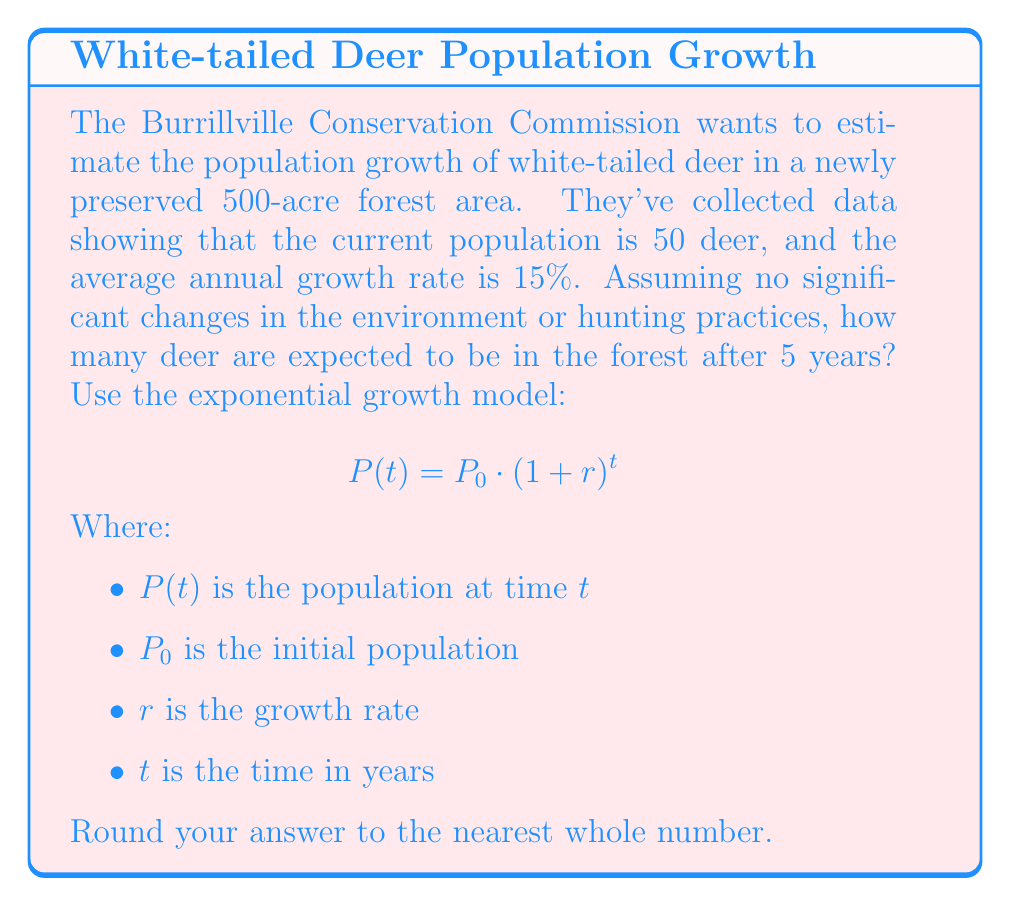Give your solution to this math problem. To solve this problem, we'll use the exponential growth model and plug in the given values:

1. Initial population, $P_0 = 50$ deer
2. Growth rate, $r = 15\% = 0.15$
3. Time, $t = 5$ years

Let's substitute these values into the formula:

$$P(5) = 50 \cdot (1 + 0.15)^5$$

Now, let's calculate step by step:

1. First, calculate $(1 + 0.15)$:
   $1 + 0.15 = 1.15$

2. Now, raise 1.15 to the power of 5:
   $1.15^5 \approx 2.0113689$

3. Finally, multiply the result by the initial population:
   $50 \cdot 2.0113689 \approx 100.568445$

4. Round to the nearest whole number:
   $100.568445 \approx 101$

Therefore, after 5 years, the expected deer population in the preserved forest area will be approximately 101 deer.
Answer: 101 deer 